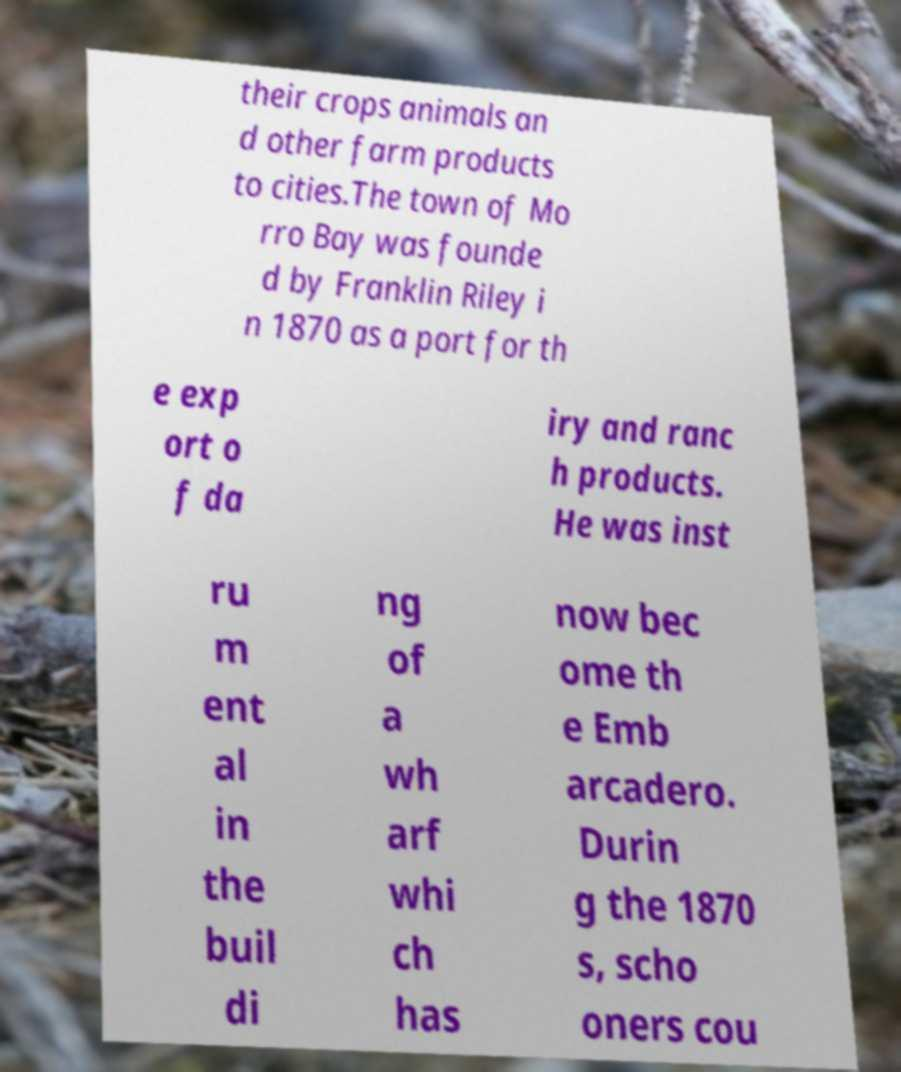There's text embedded in this image that I need extracted. Can you transcribe it verbatim? their crops animals an d other farm products to cities.The town of Mo rro Bay was founde d by Franklin Riley i n 1870 as a port for th e exp ort o f da iry and ranc h products. He was inst ru m ent al in the buil di ng of a wh arf whi ch has now bec ome th e Emb arcadero. Durin g the 1870 s, scho oners cou 